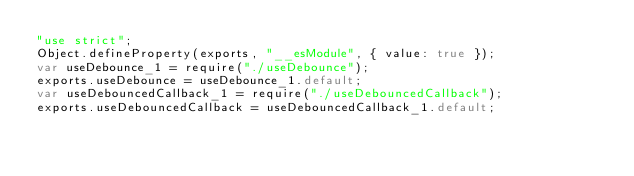<code> <loc_0><loc_0><loc_500><loc_500><_JavaScript_>"use strict";
Object.defineProperty(exports, "__esModule", { value: true });
var useDebounce_1 = require("./useDebounce");
exports.useDebounce = useDebounce_1.default;
var useDebouncedCallback_1 = require("./useDebouncedCallback");
exports.useDebouncedCallback = useDebouncedCallback_1.default;
</code> 